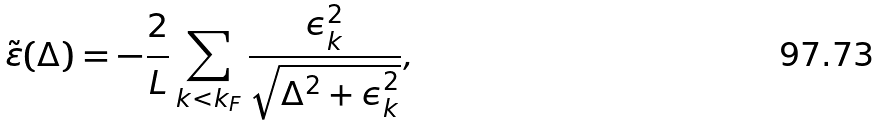<formula> <loc_0><loc_0><loc_500><loc_500>\tilde { \varepsilon } ( \Delta ) = - \frac { 2 } { L } \sum _ { k < k _ { F } } \frac { \epsilon ^ { 2 } _ { k } } { \sqrt { \Delta ^ { 2 } + \epsilon _ { k } ^ { 2 } } } ,</formula> 